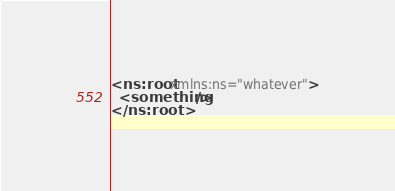Convert code to text. <code><loc_0><loc_0><loc_500><loc_500><_XML_><ns:root xmlns:ns="whatever">
  <something/>
</ns:root>
</code> 